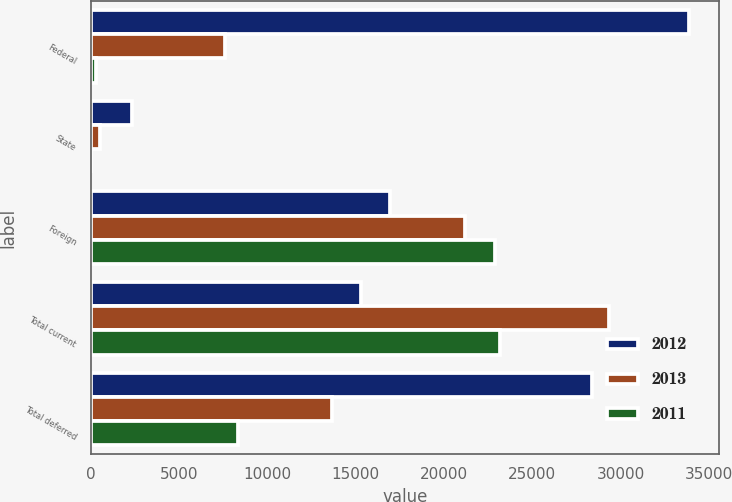<chart> <loc_0><loc_0><loc_500><loc_500><stacked_bar_chart><ecel><fcel>Federal<fcel>State<fcel>Foreign<fcel>Total current<fcel>Total deferred<nl><fcel>2012<fcel>33856<fcel>2350<fcel>16950<fcel>15305.5<fcel>28368<nl><fcel>2013<fcel>7611<fcel>544<fcel>21174<fcel>29329<fcel>13661<nl><fcel>2011<fcel>294<fcel>21<fcel>22877<fcel>23192<fcel>8339<nl></chart> 